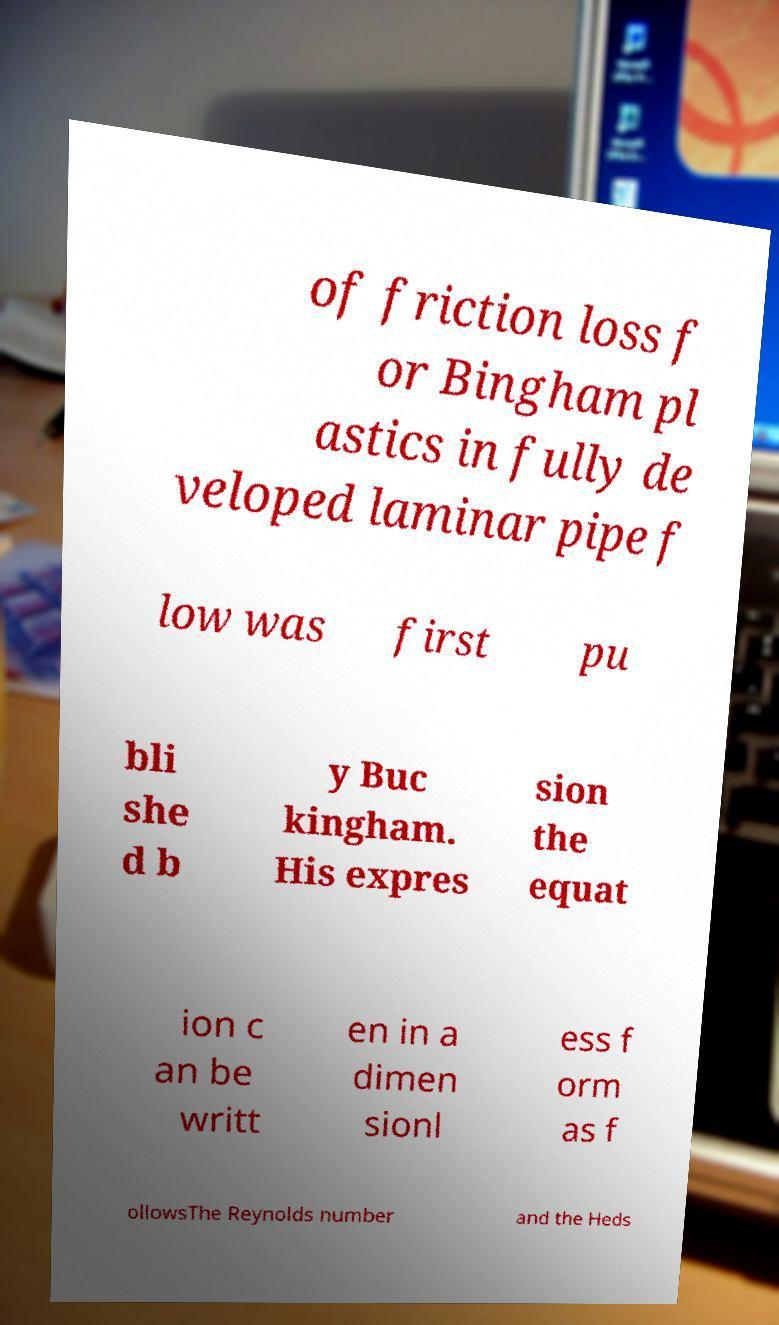There's text embedded in this image that I need extracted. Can you transcribe it verbatim? of friction loss f or Bingham pl astics in fully de veloped laminar pipe f low was first pu bli she d b y Buc kingham. His expres sion the equat ion c an be writt en in a dimen sionl ess f orm as f ollowsThe Reynolds number and the Heds 